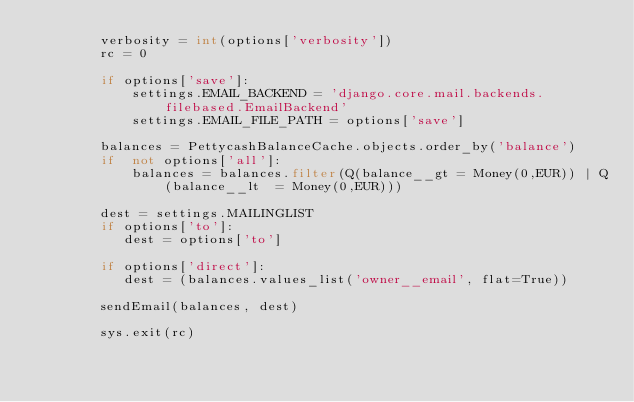<code> <loc_0><loc_0><loc_500><loc_500><_Python_>        verbosity = int(options['verbosity'])
        rc = 0

        if options['save']:
            settings.EMAIL_BACKEND = 'django.core.mail.backends.filebased.EmailBackend'
            settings.EMAIL_FILE_PATH = options['save']

        balances = PettycashBalanceCache.objects.order_by('balance')
        if  not options['all']:
            balances = balances.filter(Q(balance__gt = Money(0,EUR)) | Q(balance__lt  = Money(0,EUR)))

        dest = settings.MAILINGLIST
        if options['to']:
           dest = options['to']

        if options['direct']:
           dest = (balances.values_list('owner__email', flat=True))
        
        sendEmail(balances, dest)

        sys.exit(rc)
</code> 